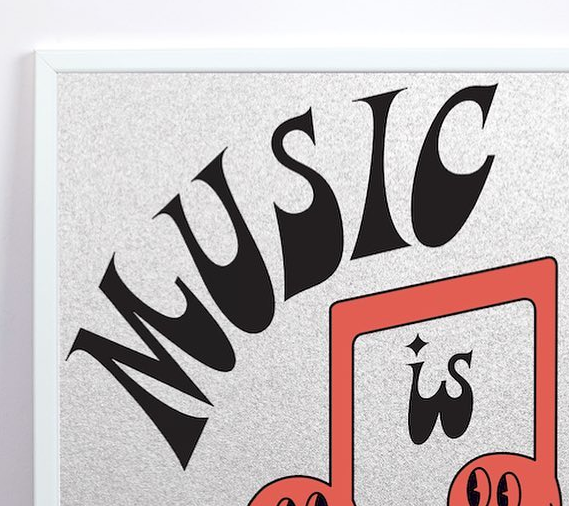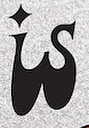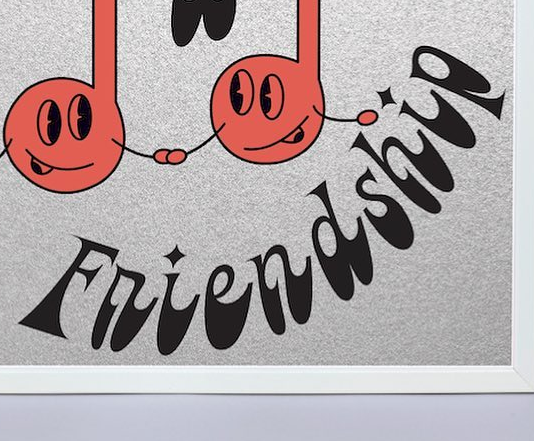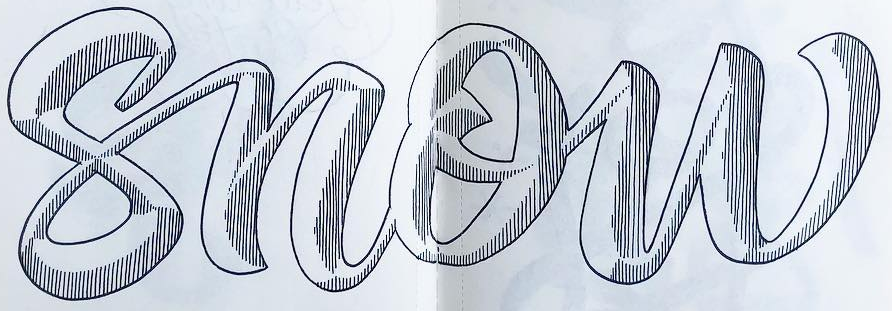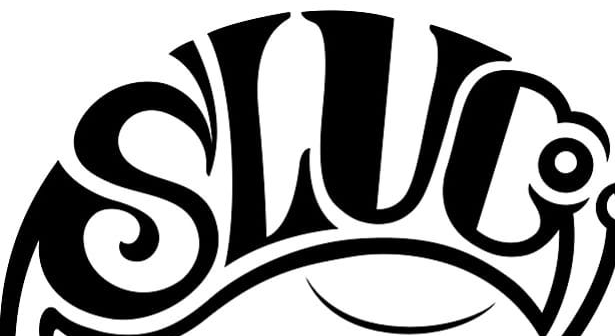Read the text content from these images in order, separated by a semicolon. MUSIC; is; Friendship; snow; SLUC 